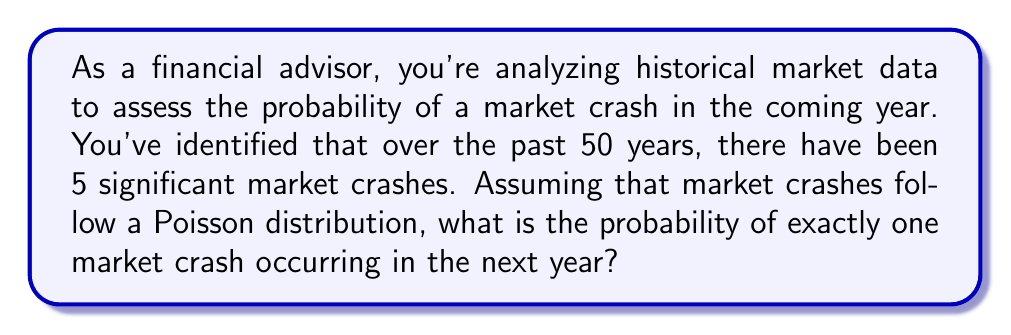Give your solution to this math problem. To solve this problem, we'll use the Poisson distribution, which is often used to model the number of events occurring within a fixed interval of time or space.

The Poisson distribution is given by the formula:

$$P(X = k) = \frac{e^{-\lambda} \lambda^k}{k!}$$

Where:
$\lambda$ = average rate of occurrence
$k$ = number of occurrences we're calculating the probability for
$e$ = Euler's number (approximately 2.71828)

Steps to solve:

1. Calculate $\lambda$ (average rate of occurrence per year):
   $\lambda = \frac{\text{Number of crashes}}{\text{Number of years}} = \frac{5}{50} = 0.1$

2. We want the probability of exactly one crash $(k = 1)$ in the next year.

3. Plug the values into the Poisson formula:

   $$P(X = 1) = \frac{e^{-0.1} (0.1)^1}{1!}$$

4. Simplify:
   $$P(X = 1) = e^{-0.1} \cdot 0.1$$

5. Calculate:
   $$P(X = 1) \approx 0.9048 \cdot 0.1 \approx 0.09048$$

6. Convert to a percentage:
   $0.09048 \cdot 100\% \approx 9.048\%$
Answer: The probability of exactly one market crash occurring in the next year is approximately 9.05%. 